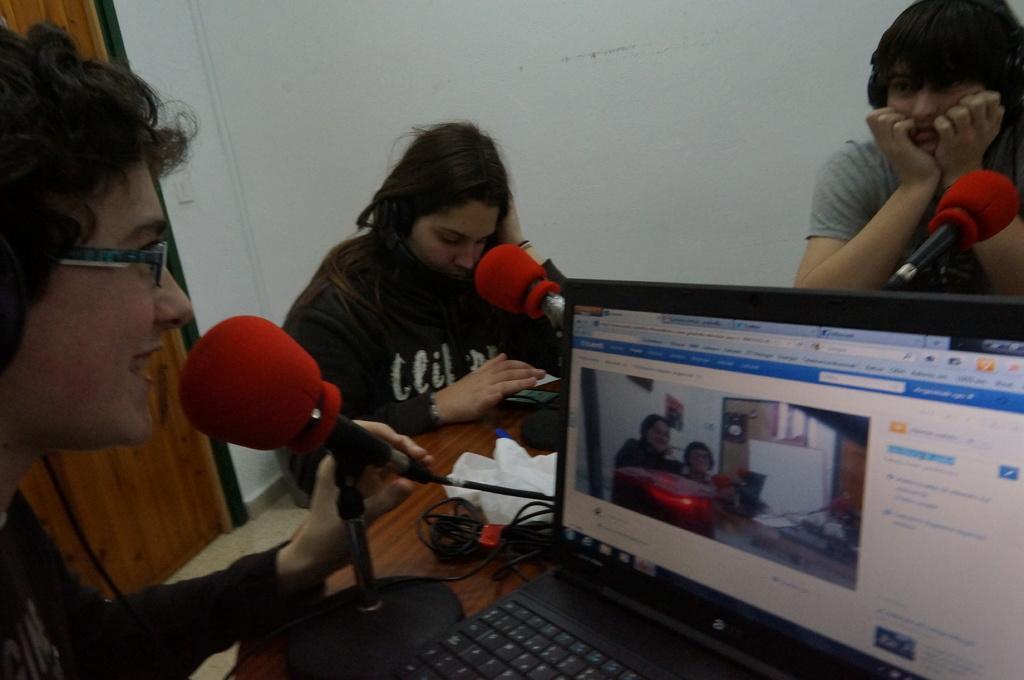Can you describe this image briefly? This image consists of three people sitting in a room. To the left, the person is talking in a mic. In the front, there is a laptop kept on the table. In the background, there is a wall along with a door. 